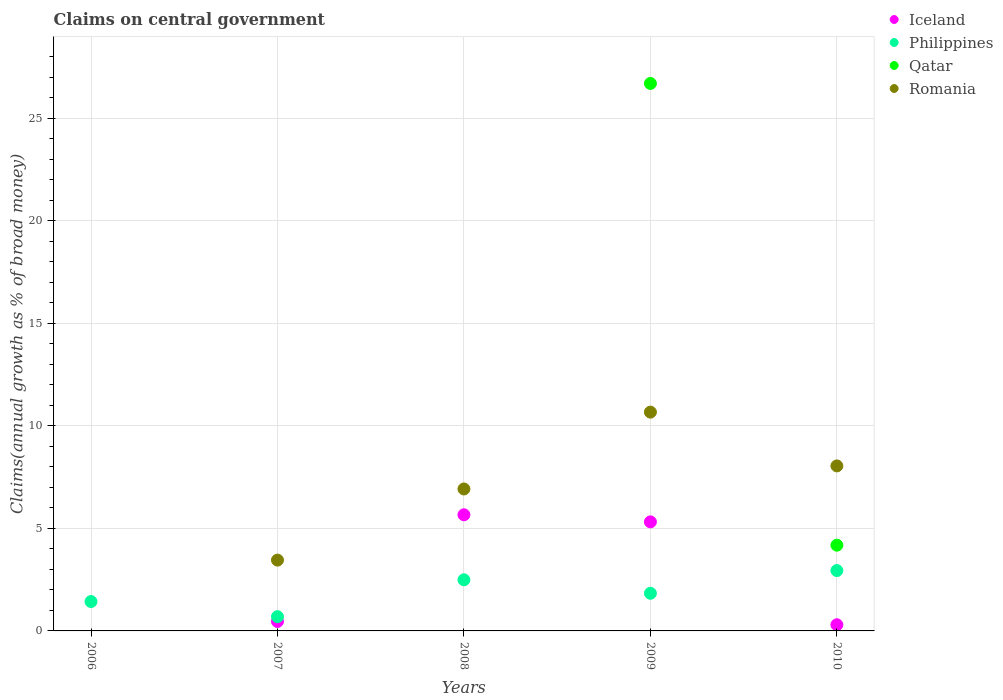How many different coloured dotlines are there?
Make the answer very short. 4. What is the percentage of broad money claimed on centeral government in Iceland in 2009?
Keep it short and to the point. 5.32. Across all years, what is the maximum percentage of broad money claimed on centeral government in Romania?
Your answer should be compact. 10.67. Across all years, what is the minimum percentage of broad money claimed on centeral government in Philippines?
Your answer should be very brief. 0.69. In which year was the percentage of broad money claimed on centeral government in Romania maximum?
Your answer should be compact. 2009. What is the total percentage of broad money claimed on centeral government in Romania in the graph?
Offer a very short reply. 29.09. What is the difference between the percentage of broad money claimed on centeral government in Iceland in 2009 and that in 2010?
Keep it short and to the point. 5.02. What is the difference between the percentage of broad money claimed on centeral government in Romania in 2006 and the percentage of broad money claimed on centeral government in Qatar in 2009?
Provide a succinct answer. -26.69. What is the average percentage of broad money claimed on centeral government in Qatar per year?
Make the answer very short. 6.17. In the year 2010, what is the difference between the percentage of broad money claimed on centeral government in Iceland and percentage of broad money claimed on centeral government in Qatar?
Give a very brief answer. -3.88. In how many years, is the percentage of broad money claimed on centeral government in Philippines greater than 15 %?
Offer a terse response. 0. What is the ratio of the percentage of broad money claimed on centeral government in Iceland in 2007 to that in 2009?
Give a very brief answer. 0.09. What is the difference between the highest and the second highest percentage of broad money claimed on centeral government in Romania?
Provide a short and direct response. 2.62. What is the difference between the highest and the lowest percentage of broad money claimed on centeral government in Iceland?
Provide a succinct answer. 5.66. In how many years, is the percentage of broad money claimed on centeral government in Philippines greater than the average percentage of broad money claimed on centeral government in Philippines taken over all years?
Offer a terse response. 2. Is it the case that in every year, the sum of the percentage of broad money claimed on centeral government in Philippines and percentage of broad money claimed on centeral government in Iceland  is greater than the sum of percentage of broad money claimed on centeral government in Qatar and percentage of broad money claimed on centeral government in Romania?
Offer a terse response. No. Is the percentage of broad money claimed on centeral government in Iceland strictly greater than the percentage of broad money claimed on centeral government in Philippines over the years?
Provide a succinct answer. No. Is the percentage of broad money claimed on centeral government in Philippines strictly less than the percentage of broad money claimed on centeral government in Iceland over the years?
Your answer should be very brief. No. How many dotlines are there?
Offer a terse response. 4. Does the graph contain grids?
Your answer should be very brief. Yes. How many legend labels are there?
Give a very brief answer. 4. How are the legend labels stacked?
Provide a succinct answer. Vertical. What is the title of the graph?
Keep it short and to the point. Claims on central government. What is the label or title of the X-axis?
Offer a terse response. Years. What is the label or title of the Y-axis?
Provide a succinct answer. Claims(annual growth as % of broad money). What is the Claims(annual growth as % of broad money) of Philippines in 2006?
Offer a terse response. 1.43. What is the Claims(annual growth as % of broad money) in Qatar in 2006?
Keep it short and to the point. 0. What is the Claims(annual growth as % of broad money) in Iceland in 2007?
Your response must be concise. 0.46. What is the Claims(annual growth as % of broad money) in Philippines in 2007?
Provide a short and direct response. 0.69. What is the Claims(annual growth as % of broad money) in Romania in 2007?
Provide a short and direct response. 3.45. What is the Claims(annual growth as % of broad money) in Iceland in 2008?
Provide a succinct answer. 5.66. What is the Claims(annual growth as % of broad money) of Philippines in 2008?
Your response must be concise. 2.49. What is the Claims(annual growth as % of broad money) in Qatar in 2008?
Keep it short and to the point. 0. What is the Claims(annual growth as % of broad money) in Romania in 2008?
Ensure brevity in your answer.  6.92. What is the Claims(annual growth as % of broad money) of Iceland in 2009?
Give a very brief answer. 5.32. What is the Claims(annual growth as % of broad money) of Philippines in 2009?
Offer a terse response. 1.84. What is the Claims(annual growth as % of broad money) in Qatar in 2009?
Provide a short and direct response. 26.69. What is the Claims(annual growth as % of broad money) of Romania in 2009?
Provide a short and direct response. 10.67. What is the Claims(annual growth as % of broad money) of Iceland in 2010?
Provide a short and direct response. 0.3. What is the Claims(annual growth as % of broad money) in Philippines in 2010?
Your answer should be very brief. 2.94. What is the Claims(annual growth as % of broad money) of Qatar in 2010?
Provide a short and direct response. 4.18. What is the Claims(annual growth as % of broad money) of Romania in 2010?
Your answer should be compact. 8.05. Across all years, what is the maximum Claims(annual growth as % of broad money) in Iceland?
Offer a very short reply. 5.66. Across all years, what is the maximum Claims(annual growth as % of broad money) of Philippines?
Provide a short and direct response. 2.94. Across all years, what is the maximum Claims(annual growth as % of broad money) in Qatar?
Offer a very short reply. 26.69. Across all years, what is the maximum Claims(annual growth as % of broad money) in Romania?
Offer a terse response. 10.67. Across all years, what is the minimum Claims(annual growth as % of broad money) of Philippines?
Your answer should be very brief. 0.69. What is the total Claims(annual growth as % of broad money) in Iceland in the graph?
Make the answer very short. 11.74. What is the total Claims(annual growth as % of broad money) of Philippines in the graph?
Keep it short and to the point. 9.4. What is the total Claims(annual growth as % of broad money) in Qatar in the graph?
Ensure brevity in your answer.  30.87. What is the total Claims(annual growth as % of broad money) in Romania in the graph?
Offer a terse response. 29.09. What is the difference between the Claims(annual growth as % of broad money) of Philippines in 2006 and that in 2007?
Ensure brevity in your answer.  0.74. What is the difference between the Claims(annual growth as % of broad money) in Philippines in 2006 and that in 2008?
Your response must be concise. -1.06. What is the difference between the Claims(annual growth as % of broad money) in Philippines in 2006 and that in 2009?
Give a very brief answer. -0.4. What is the difference between the Claims(annual growth as % of broad money) in Philippines in 2006 and that in 2010?
Ensure brevity in your answer.  -1.51. What is the difference between the Claims(annual growth as % of broad money) of Iceland in 2007 and that in 2008?
Your answer should be very brief. -5.2. What is the difference between the Claims(annual growth as % of broad money) of Philippines in 2007 and that in 2008?
Give a very brief answer. -1.8. What is the difference between the Claims(annual growth as % of broad money) of Romania in 2007 and that in 2008?
Provide a short and direct response. -3.47. What is the difference between the Claims(annual growth as % of broad money) of Iceland in 2007 and that in 2009?
Your response must be concise. -4.86. What is the difference between the Claims(annual growth as % of broad money) in Philippines in 2007 and that in 2009?
Your answer should be compact. -1.14. What is the difference between the Claims(annual growth as % of broad money) of Romania in 2007 and that in 2009?
Your response must be concise. -7.22. What is the difference between the Claims(annual growth as % of broad money) in Iceland in 2007 and that in 2010?
Give a very brief answer. 0.16. What is the difference between the Claims(annual growth as % of broad money) in Philippines in 2007 and that in 2010?
Provide a short and direct response. -2.25. What is the difference between the Claims(annual growth as % of broad money) in Romania in 2007 and that in 2010?
Provide a succinct answer. -4.59. What is the difference between the Claims(annual growth as % of broad money) in Iceland in 2008 and that in 2009?
Ensure brevity in your answer.  0.35. What is the difference between the Claims(annual growth as % of broad money) in Philippines in 2008 and that in 2009?
Your answer should be very brief. 0.66. What is the difference between the Claims(annual growth as % of broad money) in Romania in 2008 and that in 2009?
Provide a short and direct response. -3.75. What is the difference between the Claims(annual growth as % of broad money) in Iceland in 2008 and that in 2010?
Provide a short and direct response. 5.36. What is the difference between the Claims(annual growth as % of broad money) in Philippines in 2008 and that in 2010?
Your response must be concise. -0.45. What is the difference between the Claims(annual growth as % of broad money) of Romania in 2008 and that in 2010?
Your answer should be very brief. -1.12. What is the difference between the Claims(annual growth as % of broad money) of Iceland in 2009 and that in 2010?
Ensure brevity in your answer.  5.02. What is the difference between the Claims(annual growth as % of broad money) of Philippines in 2009 and that in 2010?
Your answer should be compact. -1.11. What is the difference between the Claims(annual growth as % of broad money) of Qatar in 2009 and that in 2010?
Keep it short and to the point. 22.51. What is the difference between the Claims(annual growth as % of broad money) in Romania in 2009 and that in 2010?
Your response must be concise. 2.62. What is the difference between the Claims(annual growth as % of broad money) of Philippines in 2006 and the Claims(annual growth as % of broad money) of Romania in 2007?
Make the answer very short. -2.02. What is the difference between the Claims(annual growth as % of broad money) in Philippines in 2006 and the Claims(annual growth as % of broad money) in Romania in 2008?
Keep it short and to the point. -5.49. What is the difference between the Claims(annual growth as % of broad money) in Philippines in 2006 and the Claims(annual growth as % of broad money) in Qatar in 2009?
Your answer should be very brief. -25.26. What is the difference between the Claims(annual growth as % of broad money) in Philippines in 2006 and the Claims(annual growth as % of broad money) in Romania in 2009?
Provide a short and direct response. -9.24. What is the difference between the Claims(annual growth as % of broad money) of Philippines in 2006 and the Claims(annual growth as % of broad money) of Qatar in 2010?
Ensure brevity in your answer.  -2.75. What is the difference between the Claims(annual growth as % of broad money) in Philippines in 2006 and the Claims(annual growth as % of broad money) in Romania in 2010?
Provide a succinct answer. -6.61. What is the difference between the Claims(annual growth as % of broad money) in Iceland in 2007 and the Claims(annual growth as % of broad money) in Philippines in 2008?
Offer a very short reply. -2.03. What is the difference between the Claims(annual growth as % of broad money) in Iceland in 2007 and the Claims(annual growth as % of broad money) in Romania in 2008?
Your answer should be compact. -6.46. What is the difference between the Claims(annual growth as % of broad money) of Philippines in 2007 and the Claims(annual growth as % of broad money) of Romania in 2008?
Offer a very short reply. -6.23. What is the difference between the Claims(annual growth as % of broad money) in Iceland in 2007 and the Claims(annual growth as % of broad money) in Philippines in 2009?
Your answer should be compact. -1.37. What is the difference between the Claims(annual growth as % of broad money) in Iceland in 2007 and the Claims(annual growth as % of broad money) in Qatar in 2009?
Provide a succinct answer. -26.23. What is the difference between the Claims(annual growth as % of broad money) of Iceland in 2007 and the Claims(annual growth as % of broad money) of Romania in 2009?
Offer a very short reply. -10.21. What is the difference between the Claims(annual growth as % of broad money) of Philippines in 2007 and the Claims(annual growth as % of broad money) of Qatar in 2009?
Offer a terse response. -26. What is the difference between the Claims(annual growth as % of broad money) in Philippines in 2007 and the Claims(annual growth as % of broad money) in Romania in 2009?
Your answer should be compact. -9.97. What is the difference between the Claims(annual growth as % of broad money) of Iceland in 2007 and the Claims(annual growth as % of broad money) of Philippines in 2010?
Offer a very short reply. -2.48. What is the difference between the Claims(annual growth as % of broad money) in Iceland in 2007 and the Claims(annual growth as % of broad money) in Qatar in 2010?
Provide a short and direct response. -3.72. What is the difference between the Claims(annual growth as % of broad money) in Iceland in 2007 and the Claims(annual growth as % of broad money) in Romania in 2010?
Make the answer very short. -7.59. What is the difference between the Claims(annual growth as % of broad money) of Philippines in 2007 and the Claims(annual growth as % of broad money) of Qatar in 2010?
Keep it short and to the point. -3.49. What is the difference between the Claims(annual growth as % of broad money) in Philippines in 2007 and the Claims(annual growth as % of broad money) in Romania in 2010?
Your response must be concise. -7.35. What is the difference between the Claims(annual growth as % of broad money) in Iceland in 2008 and the Claims(annual growth as % of broad money) in Philippines in 2009?
Your response must be concise. 3.83. What is the difference between the Claims(annual growth as % of broad money) of Iceland in 2008 and the Claims(annual growth as % of broad money) of Qatar in 2009?
Give a very brief answer. -21.03. What is the difference between the Claims(annual growth as % of broad money) in Iceland in 2008 and the Claims(annual growth as % of broad money) in Romania in 2009?
Give a very brief answer. -5. What is the difference between the Claims(annual growth as % of broad money) in Philippines in 2008 and the Claims(annual growth as % of broad money) in Qatar in 2009?
Offer a very short reply. -24.2. What is the difference between the Claims(annual growth as % of broad money) in Philippines in 2008 and the Claims(annual growth as % of broad money) in Romania in 2009?
Make the answer very short. -8.18. What is the difference between the Claims(annual growth as % of broad money) of Iceland in 2008 and the Claims(annual growth as % of broad money) of Philippines in 2010?
Keep it short and to the point. 2.72. What is the difference between the Claims(annual growth as % of broad money) of Iceland in 2008 and the Claims(annual growth as % of broad money) of Qatar in 2010?
Make the answer very short. 1.48. What is the difference between the Claims(annual growth as % of broad money) of Iceland in 2008 and the Claims(annual growth as % of broad money) of Romania in 2010?
Provide a succinct answer. -2.38. What is the difference between the Claims(annual growth as % of broad money) in Philippines in 2008 and the Claims(annual growth as % of broad money) in Qatar in 2010?
Ensure brevity in your answer.  -1.69. What is the difference between the Claims(annual growth as % of broad money) of Philippines in 2008 and the Claims(annual growth as % of broad money) of Romania in 2010?
Your answer should be very brief. -5.55. What is the difference between the Claims(annual growth as % of broad money) in Iceland in 2009 and the Claims(annual growth as % of broad money) in Philippines in 2010?
Give a very brief answer. 2.37. What is the difference between the Claims(annual growth as % of broad money) of Iceland in 2009 and the Claims(annual growth as % of broad money) of Qatar in 2010?
Your response must be concise. 1.14. What is the difference between the Claims(annual growth as % of broad money) of Iceland in 2009 and the Claims(annual growth as % of broad money) of Romania in 2010?
Keep it short and to the point. -2.73. What is the difference between the Claims(annual growth as % of broad money) in Philippines in 2009 and the Claims(annual growth as % of broad money) in Qatar in 2010?
Offer a very short reply. -2.34. What is the difference between the Claims(annual growth as % of broad money) of Philippines in 2009 and the Claims(annual growth as % of broad money) of Romania in 2010?
Ensure brevity in your answer.  -6.21. What is the difference between the Claims(annual growth as % of broad money) of Qatar in 2009 and the Claims(annual growth as % of broad money) of Romania in 2010?
Ensure brevity in your answer.  18.65. What is the average Claims(annual growth as % of broad money) of Iceland per year?
Make the answer very short. 2.35. What is the average Claims(annual growth as % of broad money) in Philippines per year?
Your answer should be very brief. 1.88. What is the average Claims(annual growth as % of broad money) of Qatar per year?
Offer a terse response. 6.17. What is the average Claims(annual growth as % of broad money) of Romania per year?
Provide a succinct answer. 5.82. In the year 2007, what is the difference between the Claims(annual growth as % of broad money) of Iceland and Claims(annual growth as % of broad money) of Philippines?
Your response must be concise. -0.23. In the year 2007, what is the difference between the Claims(annual growth as % of broad money) in Iceland and Claims(annual growth as % of broad money) in Romania?
Provide a succinct answer. -2.99. In the year 2007, what is the difference between the Claims(annual growth as % of broad money) of Philippines and Claims(annual growth as % of broad money) of Romania?
Provide a succinct answer. -2.76. In the year 2008, what is the difference between the Claims(annual growth as % of broad money) in Iceland and Claims(annual growth as % of broad money) in Philippines?
Provide a short and direct response. 3.17. In the year 2008, what is the difference between the Claims(annual growth as % of broad money) of Iceland and Claims(annual growth as % of broad money) of Romania?
Give a very brief answer. -1.26. In the year 2008, what is the difference between the Claims(annual growth as % of broad money) in Philippines and Claims(annual growth as % of broad money) in Romania?
Your answer should be compact. -4.43. In the year 2009, what is the difference between the Claims(annual growth as % of broad money) of Iceland and Claims(annual growth as % of broad money) of Philippines?
Offer a very short reply. 3.48. In the year 2009, what is the difference between the Claims(annual growth as % of broad money) of Iceland and Claims(annual growth as % of broad money) of Qatar?
Offer a very short reply. -21.38. In the year 2009, what is the difference between the Claims(annual growth as % of broad money) of Iceland and Claims(annual growth as % of broad money) of Romania?
Keep it short and to the point. -5.35. In the year 2009, what is the difference between the Claims(annual growth as % of broad money) of Philippines and Claims(annual growth as % of broad money) of Qatar?
Your response must be concise. -24.86. In the year 2009, what is the difference between the Claims(annual growth as % of broad money) in Philippines and Claims(annual growth as % of broad money) in Romania?
Provide a succinct answer. -8.83. In the year 2009, what is the difference between the Claims(annual growth as % of broad money) of Qatar and Claims(annual growth as % of broad money) of Romania?
Offer a very short reply. 16.03. In the year 2010, what is the difference between the Claims(annual growth as % of broad money) of Iceland and Claims(annual growth as % of broad money) of Philippines?
Ensure brevity in your answer.  -2.64. In the year 2010, what is the difference between the Claims(annual growth as % of broad money) of Iceland and Claims(annual growth as % of broad money) of Qatar?
Offer a very short reply. -3.88. In the year 2010, what is the difference between the Claims(annual growth as % of broad money) in Iceland and Claims(annual growth as % of broad money) in Romania?
Make the answer very short. -7.75. In the year 2010, what is the difference between the Claims(annual growth as % of broad money) of Philippines and Claims(annual growth as % of broad money) of Qatar?
Your answer should be compact. -1.24. In the year 2010, what is the difference between the Claims(annual growth as % of broad money) of Philippines and Claims(annual growth as % of broad money) of Romania?
Provide a succinct answer. -5.1. In the year 2010, what is the difference between the Claims(annual growth as % of broad money) in Qatar and Claims(annual growth as % of broad money) in Romania?
Ensure brevity in your answer.  -3.87. What is the ratio of the Claims(annual growth as % of broad money) of Philippines in 2006 to that in 2007?
Offer a very short reply. 2.06. What is the ratio of the Claims(annual growth as % of broad money) in Philippines in 2006 to that in 2008?
Make the answer very short. 0.57. What is the ratio of the Claims(annual growth as % of broad money) of Philippines in 2006 to that in 2009?
Keep it short and to the point. 0.78. What is the ratio of the Claims(annual growth as % of broad money) in Philippines in 2006 to that in 2010?
Your answer should be compact. 0.49. What is the ratio of the Claims(annual growth as % of broad money) in Iceland in 2007 to that in 2008?
Provide a short and direct response. 0.08. What is the ratio of the Claims(annual growth as % of broad money) of Philippines in 2007 to that in 2008?
Keep it short and to the point. 0.28. What is the ratio of the Claims(annual growth as % of broad money) of Romania in 2007 to that in 2008?
Keep it short and to the point. 0.5. What is the ratio of the Claims(annual growth as % of broad money) of Iceland in 2007 to that in 2009?
Make the answer very short. 0.09. What is the ratio of the Claims(annual growth as % of broad money) of Philippines in 2007 to that in 2009?
Ensure brevity in your answer.  0.38. What is the ratio of the Claims(annual growth as % of broad money) in Romania in 2007 to that in 2009?
Give a very brief answer. 0.32. What is the ratio of the Claims(annual growth as % of broad money) in Iceland in 2007 to that in 2010?
Your response must be concise. 1.53. What is the ratio of the Claims(annual growth as % of broad money) in Philippines in 2007 to that in 2010?
Give a very brief answer. 0.24. What is the ratio of the Claims(annual growth as % of broad money) in Romania in 2007 to that in 2010?
Provide a short and direct response. 0.43. What is the ratio of the Claims(annual growth as % of broad money) in Iceland in 2008 to that in 2009?
Your answer should be very brief. 1.06. What is the ratio of the Claims(annual growth as % of broad money) in Philippines in 2008 to that in 2009?
Your response must be concise. 1.36. What is the ratio of the Claims(annual growth as % of broad money) of Romania in 2008 to that in 2009?
Offer a terse response. 0.65. What is the ratio of the Claims(annual growth as % of broad money) of Iceland in 2008 to that in 2010?
Your answer should be very brief. 18.84. What is the ratio of the Claims(annual growth as % of broad money) of Philippines in 2008 to that in 2010?
Give a very brief answer. 0.85. What is the ratio of the Claims(annual growth as % of broad money) in Romania in 2008 to that in 2010?
Ensure brevity in your answer.  0.86. What is the ratio of the Claims(annual growth as % of broad money) in Iceland in 2009 to that in 2010?
Your response must be concise. 17.69. What is the ratio of the Claims(annual growth as % of broad money) of Philippines in 2009 to that in 2010?
Give a very brief answer. 0.62. What is the ratio of the Claims(annual growth as % of broad money) of Qatar in 2009 to that in 2010?
Provide a short and direct response. 6.39. What is the ratio of the Claims(annual growth as % of broad money) of Romania in 2009 to that in 2010?
Keep it short and to the point. 1.33. What is the difference between the highest and the second highest Claims(annual growth as % of broad money) in Iceland?
Provide a succinct answer. 0.35. What is the difference between the highest and the second highest Claims(annual growth as % of broad money) of Philippines?
Make the answer very short. 0.45. What is the difference between the highest and the second highest Claims(annual growth as % of broad money) in Romania?
Ensure brevity in your answer.  2.62. What is the difference between the highest and the lowest Claims(annual growth as % of broad money) in Iceland?
Offer a terse response. 5.66. What is the difference between the highest and the lowest Claims(annual growth as % of broad money) of Philippines?
Your response must be concise. 2.25. What is the difference between the highest and the lowest Claims(annual growth as % of broad money) of Qatar?
Make the answer very short. 26.69. What is the difference between the highest and the lowest Claims(annual growth as % of broad money) of Romania?
Offer a terse response. 10.67. 